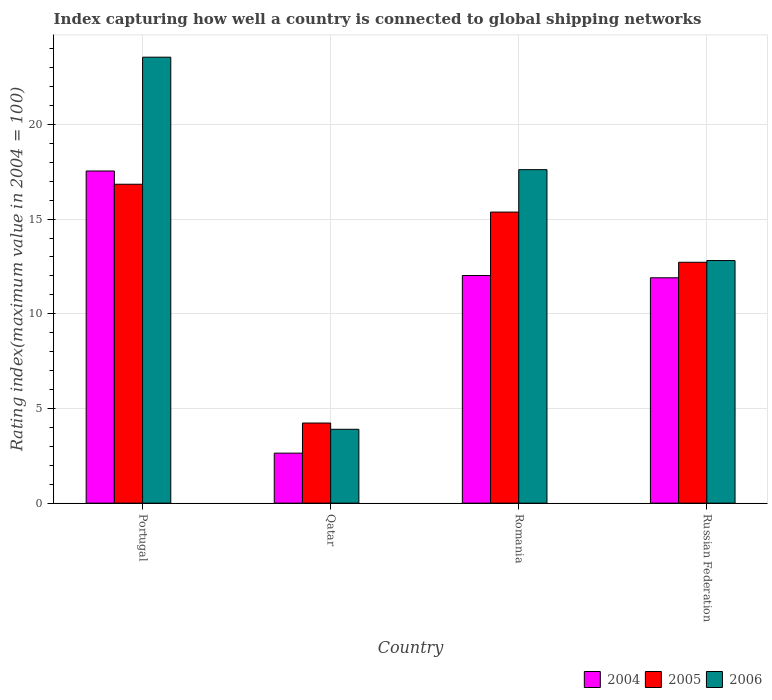What is the label of the 1st group of bars from the left?
Provide a short and direct response. Portugal. What is the rating index in 2004 in Qatar?
Make the answer very short. 2.64. Across all countries, what is the maximum rating index in 2004?
Offer a very short reply. 17.54. Across all countries, what is the minimum rating index in 2006?
Offer a terse response. 3.9. In which country was the rating index in 2004 maximum?
Provide a short and direct response. Portugal. In which country was the rating index in 2005 minimum?
Your answer should be very brief. Qatar. What is the total rating index in 2006 in the graph?
Provide a succinct answer. 57.87. What is the difference between the rating index in 2004 in Qatar and that in Russian Federation?
Ensure brevity in your answer.  -9.26. What is the average rating index in 2004 per country?
Ensure brevity in your answer.  11.03. What is the difference between the rating index of/in 2004 and rating index of/in 2006 in Qatar?
Provide a short and direct response. -1.26. In how many countries, is the rating index in 2005 greater than 9?
Make the answer very short. 3. What is the ratio of the rating index in 2006 in Romania to that in Russian Federation?
Give a very brief answer. 1.37. Is the rating index in 2005 in Portugal less than that in Qatar?
Make the answer very short. No. What is the difference between the highest and the second highest rating index in 2004?
Offer a very short reply. 5.64. What is the difference between the highest and the lowest rating index in 2004?
Your answer should be compact. 14.9. In how many countries, is the rating index in 2004 greater than the average rating index in 2004 taken over all countries?
Make the answer very short. 3. Is the sum of the rating index in 2005 in Qatar and Russian Federation greater than the maximum rating index in 2006 across all countries?
Your answer should be compact. No. What does the 3rd bar from the left in Romania represents?
Offer a very short reply. 2006. What does the 2nd bar from the right in Romania represents?
Your answer should be very brief. 2005. Is it the case that in every country, the sum of the rating index in 2004 and rating index in 2006 is greater than the rating index in 2005?
Provide a short and direct response. Yes. How many countries are there in the graph?
Provide a succinct answer. 4. What is the difference between two consecutive major ticks on the Y-axis?
Give a very brief answer. 5. Are the values on the major ticks of Y-axis written in scientific E-notation?
Your response must be concise. No. Does the graph contain any zero values?
Offer a very short reply. No. Where does the legend appear in the graph?
Provide a succinct answer. Bottom right. How are the legend labels stacked?
Your answer should be very brief. Horizontal. What is the title of the graph?
Give a very brief answer. Index capturing how well a country is connected to global shipping networks. What is the label or title of the Y-axis?
Offer a terse response. Rating index(maximum value in 2004 = 100). What is the Rating index(maximum value in 2004 = 100) in 2004 in Portugal?
Keep it short and to the point. 17.54. What is the Rating index(maximum value in 2004 = 100) of 2005 in Portugal?
Provide a succinct answer. 16.84. What is the Rating index(maximum value in 2004 = 100) of 2006 in Portugal?
Ensure brevity in your answer.  23.55. What is the Rating index(maximum value in 2004 = 100) of 2004 in Qatar?
Provide a succinct answer. 2.64. What is the Rating index(maximum value in 2004 = 100) of 2005 in Qatar?
Make the answer very short. 4.23. What is the Rating index(maximum value in 2004 = 100) in 2004 in Romania?
Provide a short and direct response. 12.02. What is the Rating index(maximum value in 2004 = 100) in 2005 in Romania?
Ensure brevity in your answer.  15.37. What is the Rating index(maximum value in 2004 = 100) of 2006 in Romania?
Offer a terse response. 17.61. What is the Rating index(maximum value in 2004 = 100) of 2004 in Russian Federation?
Give a very brief answer. 11.9. What is the Rating index(maximum value in 2004 = 100) of 2005 in Russian Federation?
Your response must be concise. 12.72. What is the Rating index(maximum value in 2004 = 100) of 2006 in Russian Federation?
Your answer should be compact. 12.81. Across all countries, what is the maximum Rating index(maximum value in 2004 = 100) in 2004?
Your answer should be very brief. 17.54. Across all countries, what is the maximum Rating index(maximum value in 2004 = 100) of 2005?
Offer a very short reply. 16.84. Across all countries, what is the maximum Rating index(maximum value in 2004 = 100) in 2006?
Your response must be concise. 23.55. Across all countries, what is the minimum Rating index(maximum value in 2004 = 100) of 2004?
Offer a very short reply. 2.64. Across all countries, what is the minimum Rating index(maximum value in 2004 = 100) in 2005?
Offer a terse response. 4.23. Across all countries, what is the minimum Rating index(maximum value in 2004 = 100) in 2006?
Keep it short and to the point. 3.9. What is the total Rating index(maximum value in 2004 = 100) of 2004 in the graph?
Your response must be concise. 44.1. What is the total Rating index(maximum value in 2004 = 100) in 2005 in the graph?
Your answer should be compact. 49.16. What is the total Rating index(maximum value in 2004 = 100) in 2006 in the graph?
Provide a succinct answer. 57.87. What is the difference between the Rating index(maximum value in 2004 = 100) of 2004 in Portugal and that in Qatar?
Your answer should be compact. 14.9. What is the difference between the Rating index(maximum value in 2004 = 100) in 2005 in Portugal and that in Qatar?
Offer a terse response. 12.61. What is the difference between the Rating index(maximum value in 2004 = 100) in 2006 in Portugal and that in Qatar?
Provide a short and direct response. 19.65. What is the difference between the Rating index(maximum value in 2004 = 100) of 2004 in Portugal and that in Romania?
Provide a short and direct response. 5.52. What is the difference between the Rating index(maximum value in 2004 = 100) in 2005 in Portugal and that in Romania?
Offer a terse response. 1.47. What is the difference between the Rating index(maximum value in 2004 = 100) in 2006 in Portugal and that in Romania?
Your answer should be very brief. 5.94. What is the difference between the Rating index(maximum value in 2004 = 100) in 2004 in Portugal and that in Russian Federation?
Ensure brevity in your answer.  5.64. What is the difference between the Rating index(maximum value in 2004 = 100) of 2005 in Portugal and that in Russian Federation?
Offer a terse response. 4.12. What is the difference between the Rating index(maximum value in 2004 = 100) of 2006 in Portugal and that in Russian Federation?
Make the answer very short. 10.74. What is the difference between the Rating index(maximum value in 2004 = 100) of 2004 in Qatar and that in Romania?
Offer a terse response. -9.38. What is the difference between the Rating index(maximum value in 2004 = 100) in 2005 in Qatar and that in Romania?
Provide a short and direct response. -11.14. What is the difference between the Rating index(maximum value in 2004 = 100) in 2006 in Qatar and that in Romania?
Offer a very short reply. -13.71. What is the difference between the Rating index(maximum value in 2004 = 100) in 2004 in Qatar and that in Russian Federation?
Keep it short and to the point. -9.26. What is the difference between the Rating index(maximum value in 2004 = 100) of 2005 in Qatar and that in Russian Federation?
Keep it short and to the point. -8.49. What is the difference between the Rating index(maximum value in 2004 = 100) in 2006 in Qatar and that in Russian Federation?
Your answer should be very brief. -8.91. What is the difference between the Rating index(maximum value in 2004 = 100) of 2004 in Romania and that in Russian Federation?
Provide a short and direct response. 0.12. What is the difference between the Rating index(maximum value in 2004 = 100) of 2005 in Romania and that in Russian Federation?
Your answer should be very brief. 2.65. What is the difference between the Rating index(maximum value in 2004 = 100) of 2004 in Portugal and the Rating index(maximum value in 2004 = 100) of 2005 in Qatar?
Ensure brevity in your answer.  13.31. What is the difference between the Rating index(maximum value in 2004 = 100) in 2004 in Portugal and the Rating index(maximum value in 2004 = 100) in 2006 in Qatar?
Offer a terse response. 13.64. What is the difference between the Rating index(maximum value in 2004 = 100) in 2005 in Portugal and the Rating index(maximum value in 2004 = 100) in 2006 in Qatar?
Provide a succinct answer. 12.94. What is the difference between the Rating index(maximum value in 2004 = 100) of 2004 in Portugal and the Rating index(maximum value in 2004 = 100) of 2005 in Romania?
Keep it short and to the point. 2.17. What is the difference between the Rating index(maximum value in 2004 = 100) in 2004 in Portugal and the Rating index(maximum value in 2004 = 100) in 2006 in Romania?
Offer a very short reply. -0.07. What is the difference between the Rating index(maximum value in 2004 = 100) in 2005 in Portugal and the Rating index(maximum value in 2004 = 100) in 2006 in Romania?
Give a very brief answer. -0.77. What is the difference between the Rating index(maximum value in 2004 = 100) of 2004 in Portugal and the Rating index(maximum value in 2004 = 100) of 2005 in Russian Federation?
Ensure brevity in your answer.  4.82. What is the difference between the Rating index(maximum value in 2004 = 100) of 2004 in Portugal and the Rating index(maximum value in 2004 = 100) of 2006 in Russian Federation?
Make the answer very short. 4.73. What is the difference between the Rating index(maximum value in 2004 = 100) in 2005 in Portugal and the Rating index(maximum value in 2004 = 100) in 2006 in Russian Federation?
Offer a terse response. 4.03. What is the difference between the Rating index(maximum value in 2004 = 100) of 2004 in Qatar and the Rating index(maximum value in 2004 = 100) of 2005 in Romania?
Offer a terse response. -12.73. What is the difference between the Rating index(maximum value in 2004 = 100) in 2004 in Qatar and the Rating index(maximum value in 2004 = 100) in 2006 in Romania?
Keep it short and to the point. -14.97. What is the difference between the Rating index(maximum value in 2004 = 100) of 2005 in Qatar and the Rating index(maximum value in 2004 = 100) of 2006 in Romania?
Your response must be concise. -13.38. What is the difference between the Rating index(maximum value in 2004 = 100) in 2004 in Qatar and the Rating index(maximum value in 2004 = 100) in 2005 in Russian Federation?
Your response must be concise. -10.08. What is the difference between the Rating index(maximum value in 2004 = 100) in 2004 in Qatar and the Rating index(maximum value in 2004 = 100) in 2006 in Russian Federation?
Ensure brevity in your answer.  -10.17. What is the difference between the Rating index(maximum value in 2004 = 100) in 2005 in Qatar and the Rating index(maximum value in 2004 = 100) in 2006 in Russian Federation?
Provide a short and direct response. -8.58. What is the difference between the Rating index(maximum value in 2004 = 100) of 2004 in Romania and the Rating index(maximum value in 2004 = 100) of 2005 in Russian Federation?
Give a very brief answer. -0.7. What is the difference between the Rating index(maximum value in 2004 = 100) in 2004 in Romania and the Rating index(maximum value in 2004 = 100) in 2006 in Russian Federation?
Your answer should be very brief. -0.79. What is the difference between the Rating index(maximum value in 2004 = 100) in 2005 in Romania and the Rating index(maximum value in 2004 = 100) in 2006 in Russian Federation?
Ensure brevity in your answer.  2.56. What is the average Rating index(maximum value in 2004 = 100) of 2004 per country?
Keep it short and to the point. 11.03. What is the average Rating index(maximum value in 2004 = 100) in 2005 per country?
Keep it short and to the point. 12.29. What is the average Rating index(maximum value in 2004 = 100) of 2006 per country?
Provide a succinct answer. 14.47. What is the difference between the Rating index(maximum value in 2004 = 100) in 2004 and Rating index(maximum value in 2004 = 100) in 2005 in Portugal?
Give a very brief answer. 0.7. What is the difference between the Rating index(maximum value in 2004 = 100) of 2004 and Rating index(maximum value in 2004 = 100) of 2006 in Portugal?
Keep it short and to the point. -6.01. What is the difference between the Rating index(maximum value in 2004 = 100) of 2005 and Rating index(maximum value in 2004 = 100) of 2006 in Portugal?
Give a very brief answer. -6.71. What is the difference between the Rating index(maximum value in 2004 = 100) of 2004 and Rating index(maximum value in 2004 = 100) of 2005 in Qatar?
Offer a terse response. -1.59. What is the difference between the Rating index(maximum value in 2004 = 100) of 2004 and Rating index(maximum value in 2004 = 100) of 2006 in Qatar?
Keep it short and to the point. -1.26. What is the difference between the Rating index(maximum value in 2004 = 100) of 2005 and Rating index(maximum value in 2004 = 100) of 2006 in Qatar?
Your answer should be compact. 0.33. What is the difference between the Rating index(maximum value in 2004 = 100) of 2004 and Rating index(maximum value in 2004 = 100) of 2005 in Romania?
Provide a succinct answer. -3.35. What is the difference between the Rating index(maximum value in 2004 = 100) of 2004 and Rating index(maximum value in 2004 = 100) of 2006 in Romania?
Make the answer very short. -5.59. What is the difference between the Rating index(maximum value in 2004 = 100) in 2005 and Rating index(maximum value in 2004 = 100) in 2006 in Romania?
Keep it short and to the point. -2.24. What is the difference between the Rating index(maximum value in 2004 = 100) of 2004 and Rating index(maximum value in 2004 = 100) of 2005 in Russian Federation?
Ensure brevity in your answer.  -0.82. What is the difference between the Rating index(maximum value in 2004 = 100) of 2004 and Rating index(maximum value in 2004 = 100) of 2006 in Russian Federation?
Provide a succinct answer. -0.91. What is the difference between the Rating index(maximum value in 2004 = 100) of 2005 and Rating index(maximum value in 2004 = 100) of 2006 in Russian Federation?
Your answer should be very brief. -0.09. What is the ratio of the Rating index(maximum value in 2004 = 100) of 2004 in Portugal to that in Qatar?
Your answer should be compact. 6.64. What is the ratio of the Rating index(maximum value in 2004 = 100) of 2005 in Portugal to that in Qatar?
Your response must be concise. 3.98. What is the ratio of the Rating index(maximum value in 2004 = 100) in 2006 in Portugal to that in Qatar?
Offer a terse response. 6.04. What is the ratio of the Rating index(maximum value in 2004 = 100) of 2004 in Portugal to that in Romania?
Your answer should be very brief. 1.46. What is the ratio of the Rating index(maximum value in 2004 = 100) in 2005 in Portugal to that in Romania?
Make the answer very short. 1.1. What is the ratio of the Rating index(maximum value in 2004 = 100) in 2006 in Portugal to that in Romania?
Keep it short and to the point. 1.34. What is the ratio of the Rating index(maximum value in 2004 = 100) in 2004 in Portugal to that in Russian Federation?
Offer a very short reply. 1.47. What is the ratio of the Rating index(maximum value in 2004 = 100) in 2005 in Portugal to that in Russian Federation?
Your response must be concise. 1.32. What is the ratio of the Rating index(maximum value in 2004 = 100) in 2006 in Portugal to that in Russian Federation?
Provide a succinct answer. 1.84. What is the ratio of the Rating index(maximum value in 2004 = 100) of 2004 in Qatar to that in Romania?
Keep it short and to the point. 0.22. What is the ratio of the Rating index(maximum value in 2004 = 100) of 2005 in Qatar to that in Romania?
Give a very brief answer. 0.28. What is the ratio of the Rating index(maximum value in 2004 = 100) in 2006 in Qatar to that in Romania?
Offer a very short reply. 0.22. What is the ratio of the Rating index(maximum value in 2004 = 100) of 2004 in Qatar to that in Russian Federation?
Your response must be concise. 0.22. What is the ratio of the Rating index(maximum value in 2004 = 100) in 2005 in Qatar to that in Russian Federation?
Provide a short and direct response. 0.33. What is the ratio of the Rating index(maximum value in 2004 = 100) in 2006 in Qatar to that in Russian Federation?
Offer a terse response. 0.3. What is the ratio of the Rating index(maximum value in 2004 = 100) in 2005 in Romania to that in Russian Federation?
Provide a succinct answer. 1.21. What is the ratio of the Rating index(maximum value in 2004 = 100) of 2006 in Romania to that in Russian Federation?
Your answer should be very brief. 1.37. What is the difference between the highest and the second highest Rating index(maximum value in 2004 = 100) of 2004?
Your response must be concise. 5.52. What is the difference between the highest and the second highest Rating index(maximum value in 2004 = 100) of 2005?
Offer a terse response. 1.47. What is the difference between the highest and the second highest Rating index(maximum value in 2004 = 100) in 2006?
Give a very brief answer. 5.94. What is the difference between the highest and the lowest Rating index(maximum value in 2004 = 100) of 2005?
Offer a very short reply. 12.61. What is the difference between the highest and the lowest Rating index(maximum value in 2004 = 100) of 2006?
Offer a terse response. 19.65. 